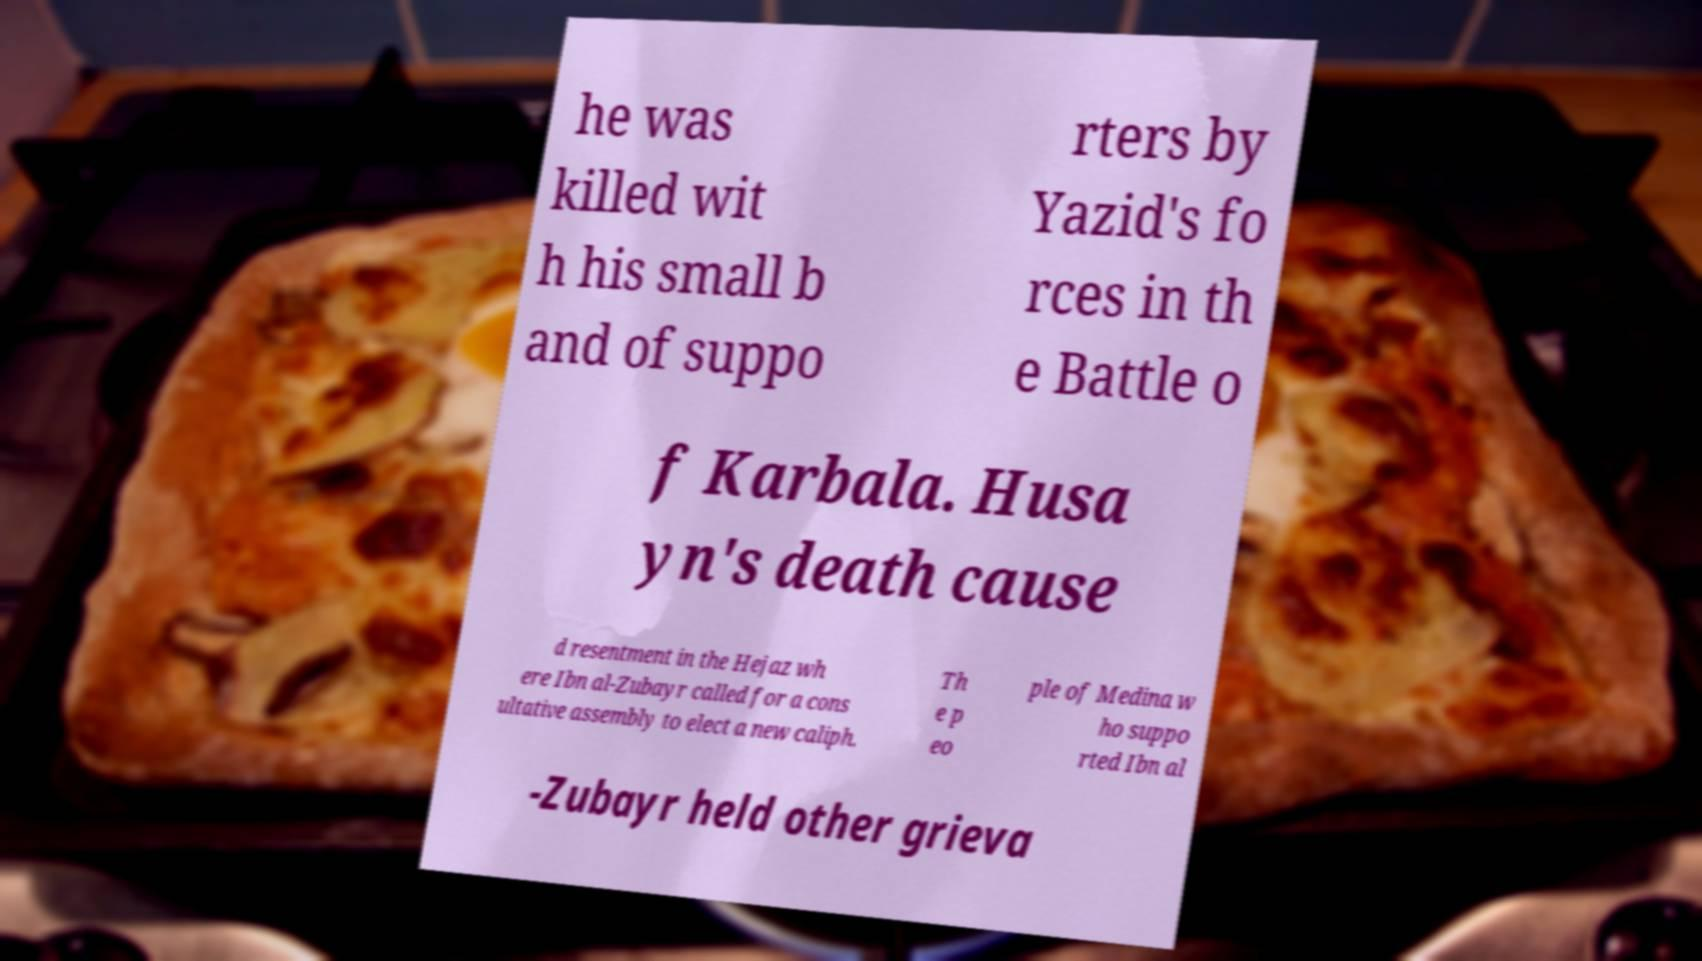Could you extract and type out the text from this image? he was killed wit h his small b and of suppo rters by Yazid's fo rces in th e Battle o f Karbala. Husa yn's death cause d resentment in the Hejaz wh ere Ibn al-Zubayr called for a cons ultative assembly to elect a new caliph. Th e p eo ple of Medina w ho suppo rted Ibn al -Zubayr held other grieva 